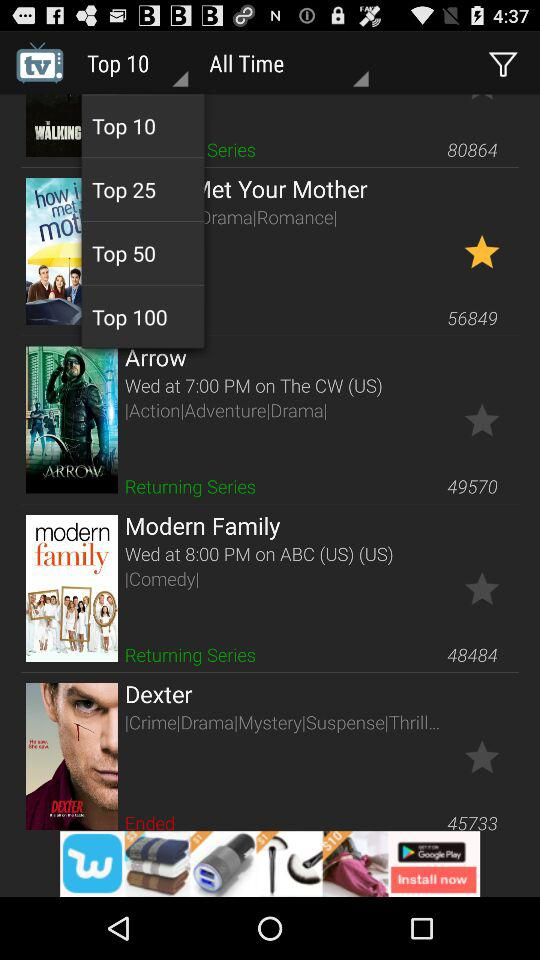What is the genre of "Modern Family"? The genre of "Modern Family" is comedy. 